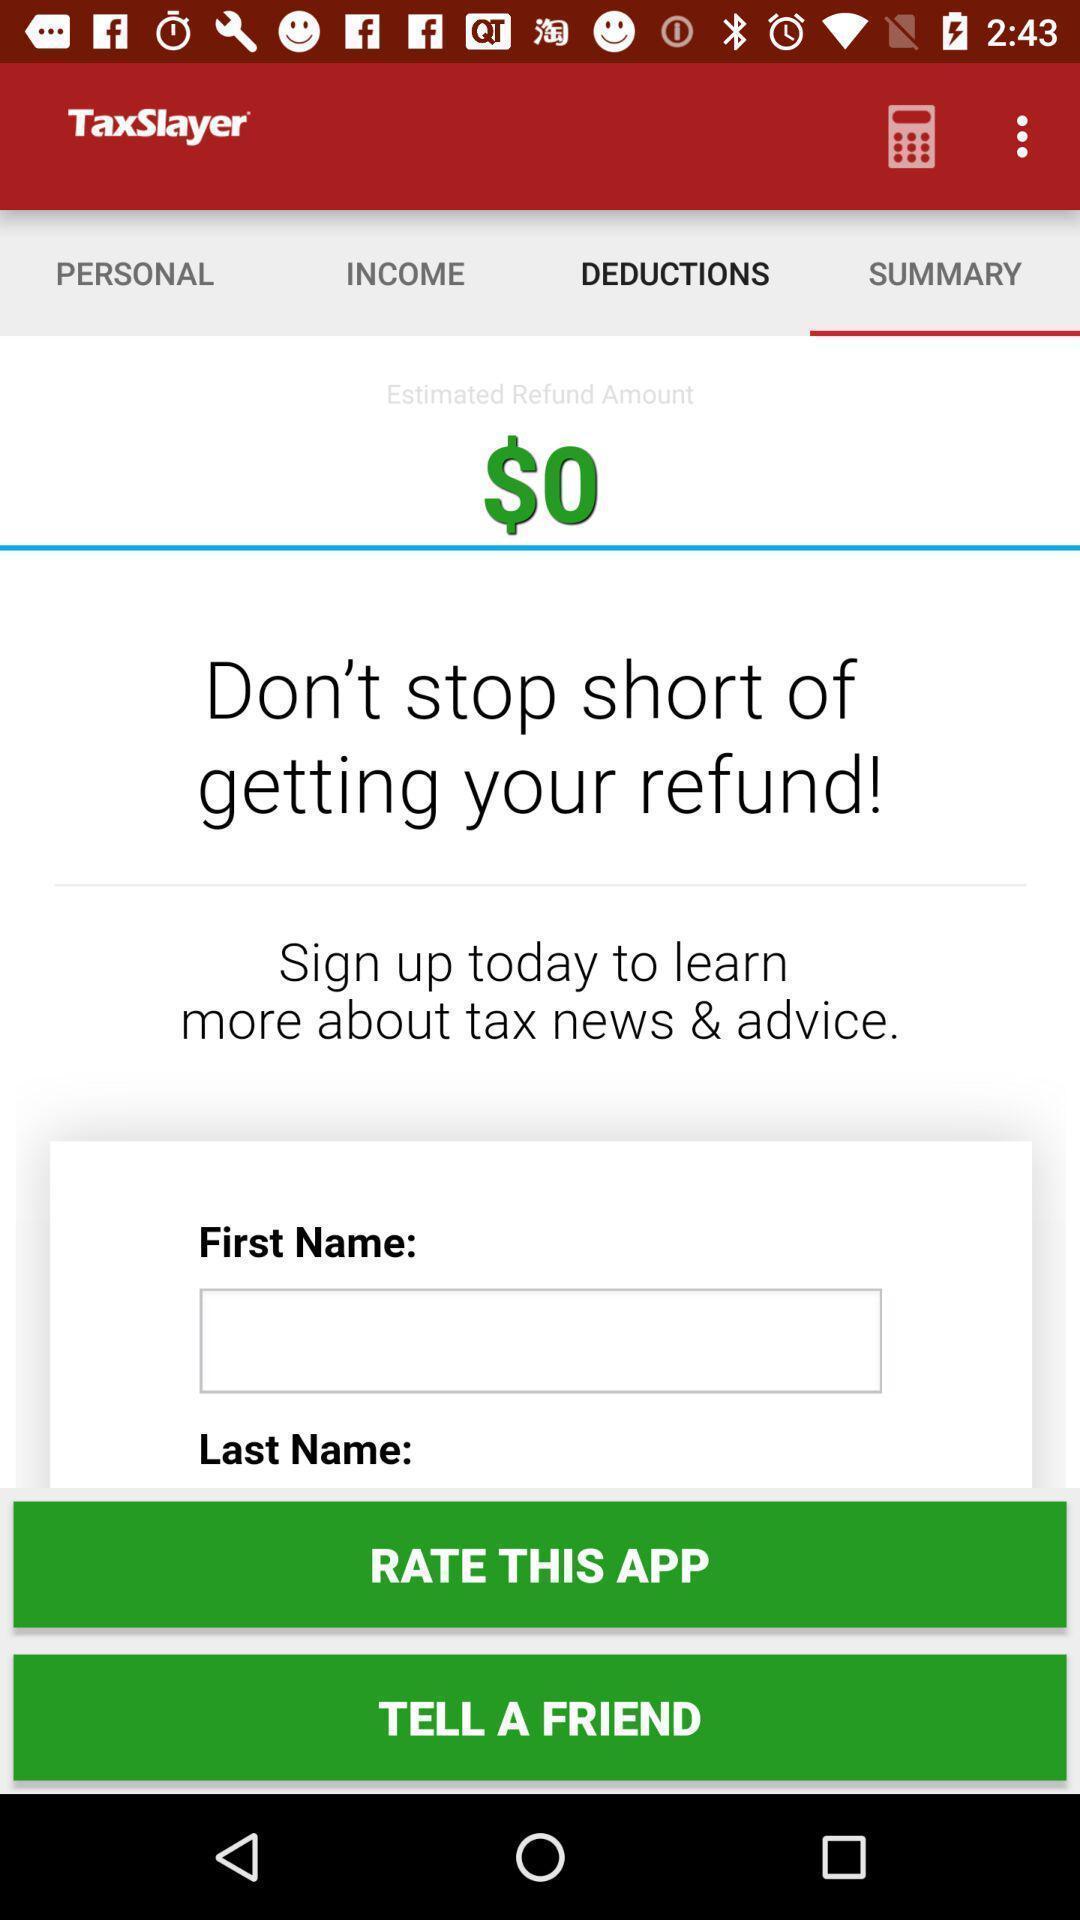Summarize the information in this screenshot. Summary page of a tax return app. 